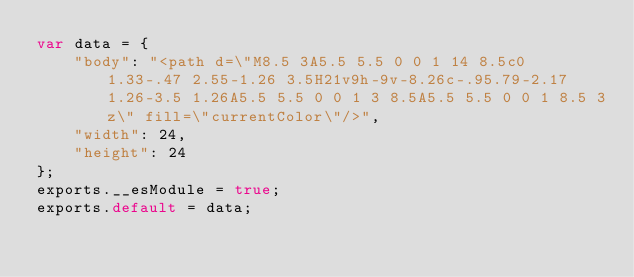Convert code to text. <code><loc_0><loc_0><loc_500><loc_500><_JavaScript_>var data = {
	"body": "<path d=\"M8.5 3A5.5 5.5 0 0 1 14 8.5c0 1.33-.47 2.55-1.26 3.5H21v9h-9v-8.26c-.95.79-2.17 1.26-3.5 1.26A5.5 5.5 0 0 1 3 8.5A5.5 5.5 0 0 1 8.5 3z\" fill=\"currentColor\"/>",
	"width": 24,
	"height": 24
};
exports.__esModule = true;
exports.default = data;
</code> 